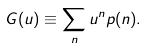Convert formula to latex. <formula><loc_0><loc_0><loc_500><loc_500>G ( u ) \equiv \sum _ { n } u ^ { n } p ( n ) .</formula> 